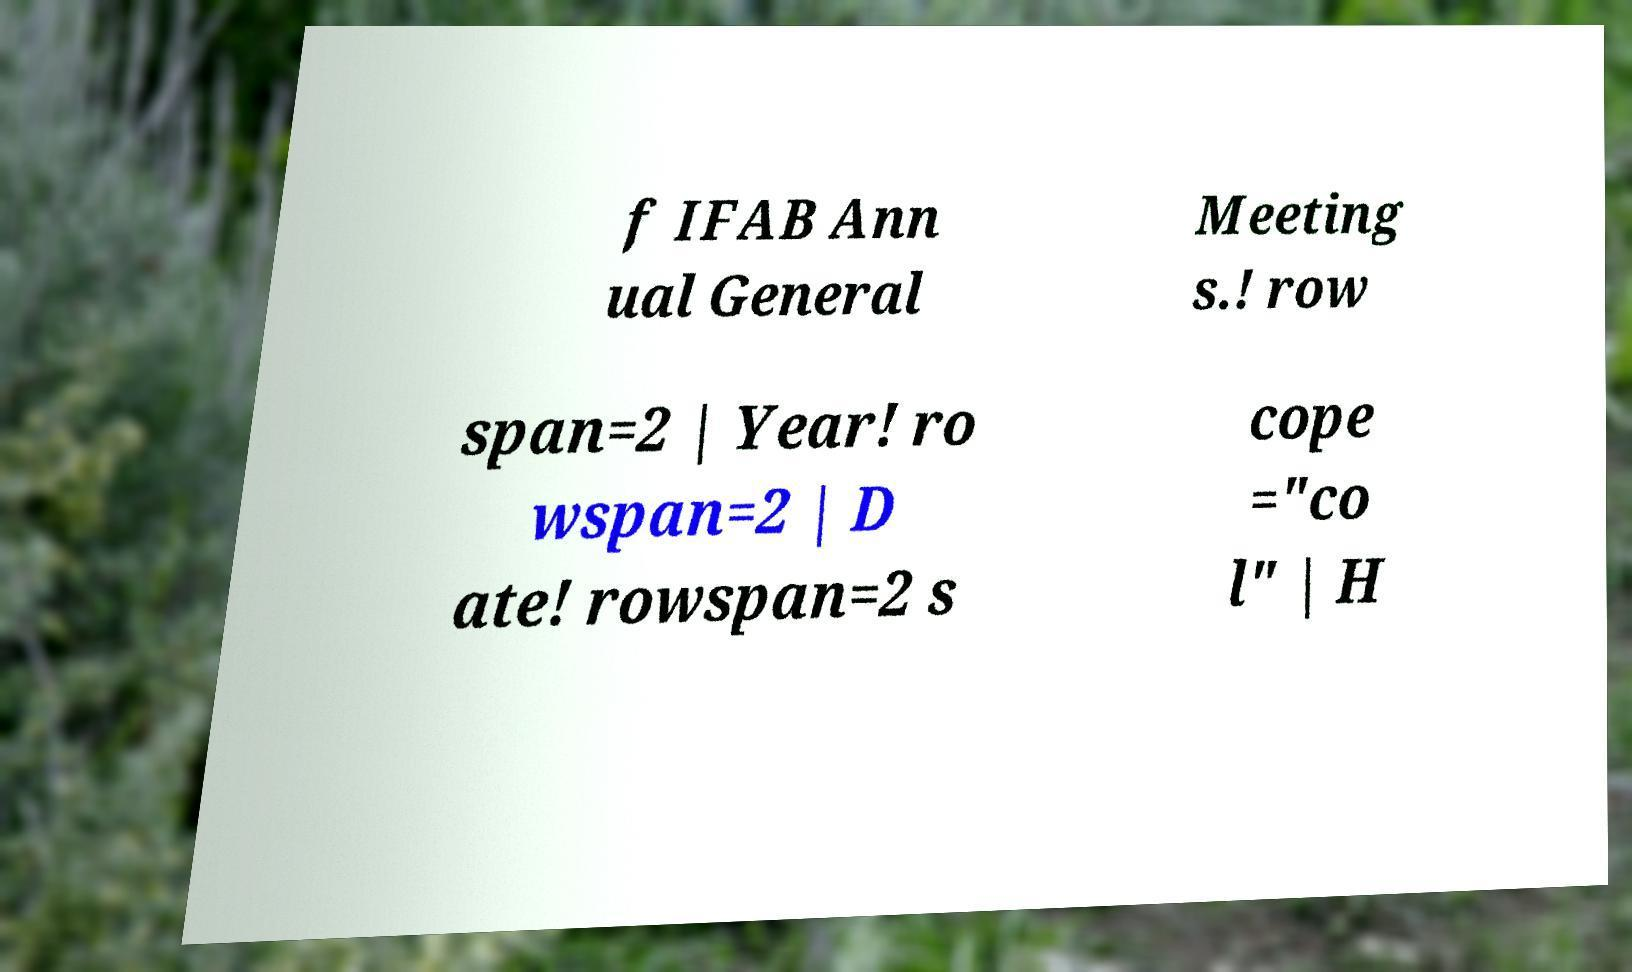Please read and relay the text visible in this image. What does it say? f IFAB Ann ual General Meeting s.! row span=2 | Year! ro wspan=2 | D ate! rowspan=2 s cope ="co l" | H 